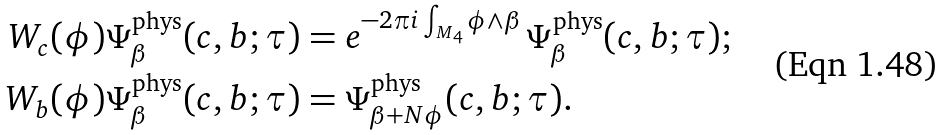Convert formula to latex. <formula><loc_0><loc_0><loc_500><loc_500>W _ { c } ( \phi ) \Psi _ { \beta } ^ { \text {phys} } ( c , b ; \tau ) & = e ^ { - 2 \pi i \int _ { M _ { 4 } } \phi \wedge \beta } \, \Psi _ { \beta } ^ { \text {phys} } ( c , b ; \tau ) ; \\ W _ { b } ( \phi ) \Psi _ { \beta } ^ { \text {phys} } ( c , b ; \tau ) & = \Psi _ { \beta + N \phi } ^ { \text {phys} } ( c , b ; \tau ) .</formula> 